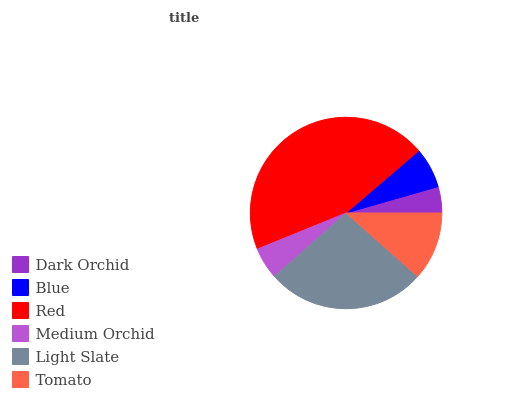Is Dark Orchid the minimum?
Answer yes or no. Yes. Is Red the maximum?
Answer yes or no. Yes. Is Blue the minimum?
Answer yes or no. No. Is Blue the maximum?
Answer yes or no. No. Is Blue greater than Dark Orchid?
Answer yes or no. Yes. Is Dark Orchid less than Blue?
Answer yes or no. Yes. Is Dark Orchid greater than Blue?
Answer yes or no. No. Is Blue less than Dark Orchid?
Answer yes or no. No. Is Tomato the high median?
Answer yes or no. Yes. Is Blue the low median?
Answer yes or no. Yes. Is Dark Orchid the high median?
Answer yes or no. No. Is Light Slate the low median?
Answer yes or no. No. 